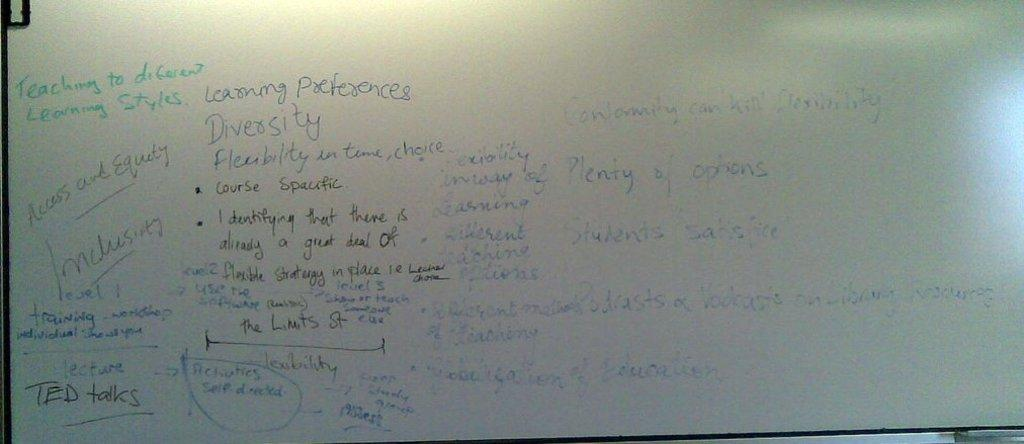<image>
Render a clear and concise summary of the photo. White board that has the word "teaching" in green. 